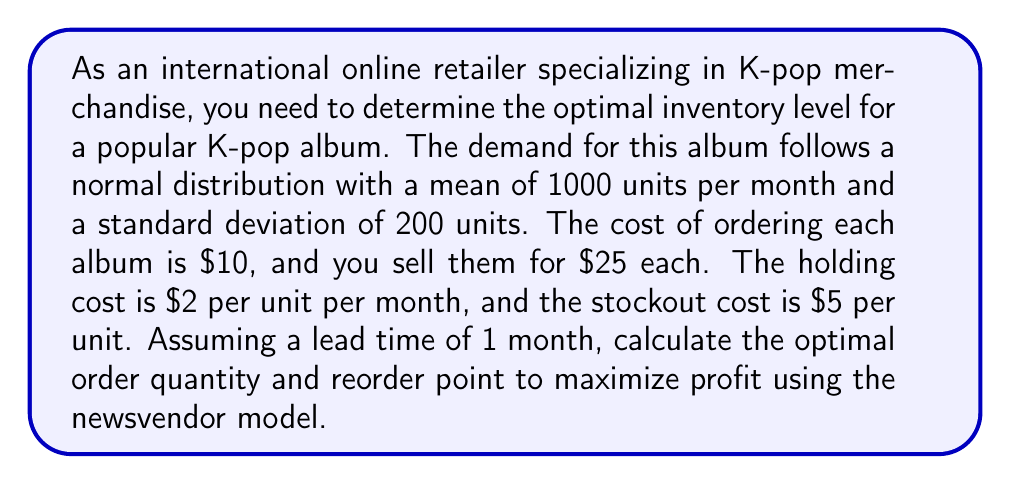What is the answer to this math problem? To solve this problem, we'll use the newsvendor model, which is appropriate for determining optimal inventory levels for products with uncertain demand. We'll follow these steps:

1. Calculate the critical fractile (CF):
The critical fractile is given by:

$$ CF = \frac{p - c}{p - c + h + s} $$

Where:
$p$ = selling price = $25
$c$ = cost price = $10
$h$ = holding cost = $2
$s$ = stockout cost = $5

$$ CF = \frac{25 - 10}{25 - 10 + 2 + 5} = \frac{15}{22} \approx 0.6818 $$

2. Find the z-score corresponding to the critical fractile:
Using a standard normal distribution table or calculator, we find that the z-score for 0.6818 is approximately 0.47.

3. Calculate the optimal order quantity (Q*):
$$ Q* = \mu + z\sigma $$

Where:
$\mu$ = mean demand = 1000
$\sigma$ = standard deviation of demand = 200
$z$ = z-score = 0.47

$$ Q* = 1000 + (0.47 \times 200) = 1094 \text{ units} $$

4. Calculate the reorder point (ROP):
Since the lead time is 1 month, which is the same as our demand period, the reorder point will be equal to the optimal order quantity.

$$ ROP = Q* = 1094 \text{ units} $$

Therefore, the optimal inventory strategy is to place an order of 1094 units whenever the inventory level drops to 1094 units.
Answer: Optimal order quantity (Q*): 1094 units
Reorder point (ROP): 1094 units 